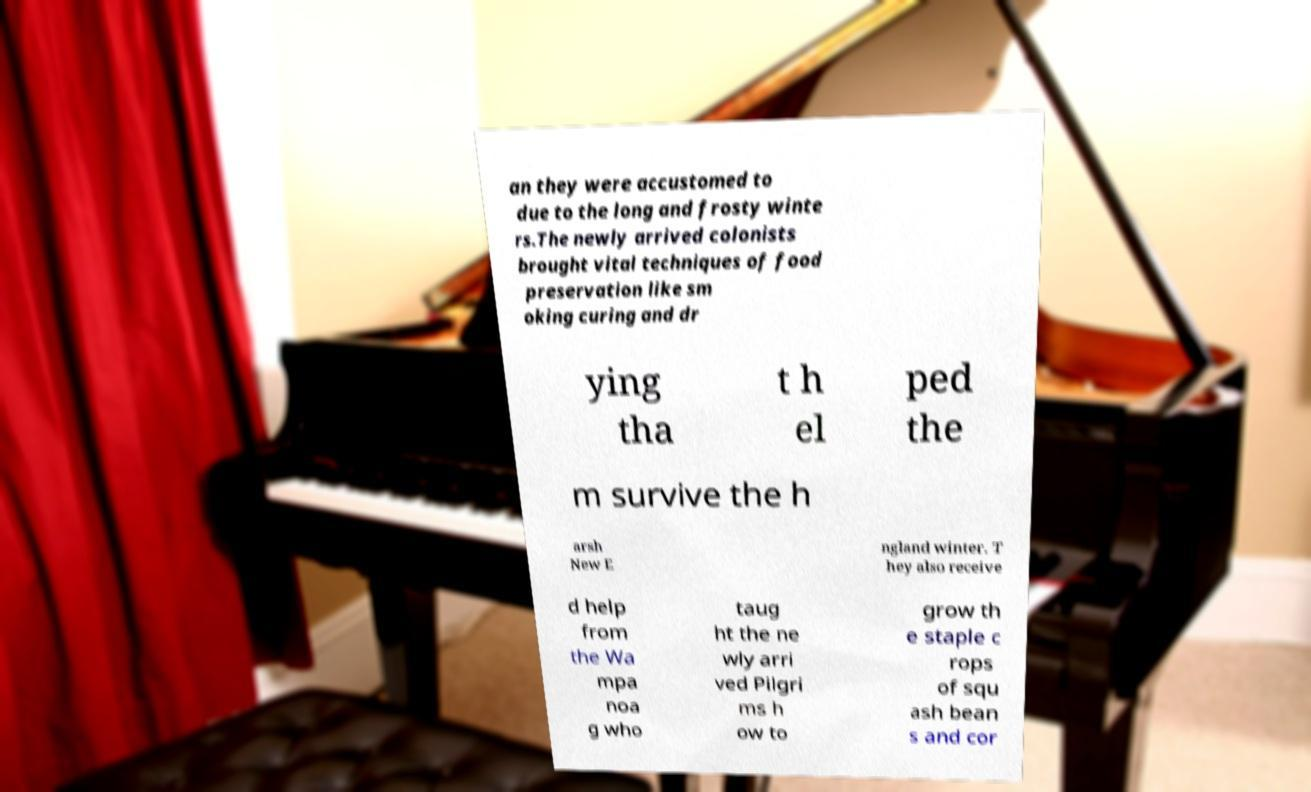Could you assist in decoding the text presented in this image and type it out clearly? an they were accustomed to due to the long and frosty winte rs.The newly arrived colonists brought vital techniques of food preservation like sm oking curing and dr ying tha t h el ped the m survive the h arsh New E ngland winter. T hey also receive d help from the Wa mpa noa g who taug ht the ne wly arri ved Pilgri ms h ow to grow th e staple c rops of squ ash bean s and cor 